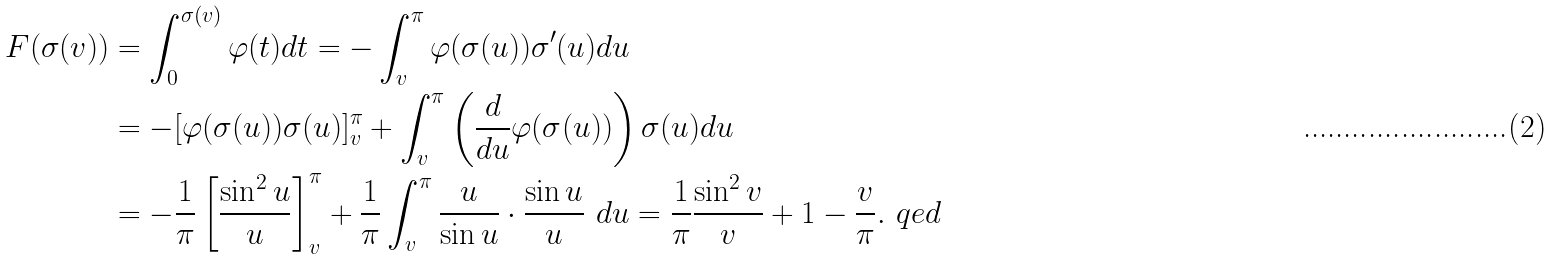Convert formula to latex. <formula><loc_0><loc_0><loc_500><loc_500>F ( \sigma ( v ) ) & = \int ^ { \sigma ( v ) } _ { 0 } \varphi ( t ) d t = - \int ^ { \pi } _ { v } \varphi ( \sigma ( u ) ) \sigma ^ { \prime } ( u ) d u \\ & = - [ \varphi ( \sigma ( u ) ) \sigma ( u ) ] ^ { \pi } _ { v } + \int ^ { \pi } _ { v } \left ( \frac { d } { d u } \varphi ( \sigma ( u ) ) \right ) \sigma ( u ) d u \\ & = - \frac { 1 } { \pi } \left [ \frac { \sin ^ { 2 } u } u \right ] ^ { \pi } _ { v } + \frac { 1 } { \pi } \int ^ { \pi } _ { v } \frac { u } { \sin u } \cdot \frac { \sin u } u \ d u = \frac { 1 } { \pi } \frac { \sin ^ { 2 } v } v + 1 - \frac { v } \pi . \ q e d</formula> 